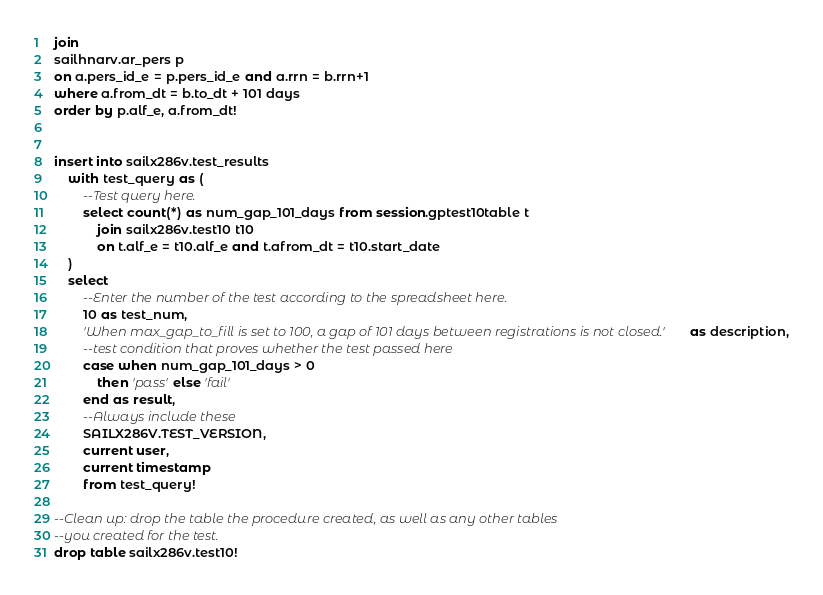<code> <loc_0><loc_0><loc_500><loc_500><_SQL_>join
sailhnarv.ar_pers p
on a.pers_id_e = p.pers_id_e and a.rrn = b.rrn+1
where a.from_dt = b.to_dt + 101 days
order by p.alf_e, a.from_dt!


insert into sailx286v.test_results
	with test_query as (
		--Test query here.
		select count(*) as num_gap_101_days from session.gptest10table t
			join sailx286v.test10 t10
			on t.alf_e = t10.alf_e and t.afrom_dt = t10.start_date
	)
	select 
		--Enter the number of the test according to the spreadsheet here.
		10 as test_num,
		'When max_gap_to_fill is set to 100, a gap of 101 days between registrations is not closed.' as description,
		--test condition that proves whether the test passed here
		case when num_gap_101_days > 0 	
			then 'pass' else 'fail'
		end as result,
		--Always include these
		SAILX286V.TEST_VERSION,
		current user,
		current timestamp
		from test_query!

--Clean up: drop the table the procedure created, as well as any other tables
--you created for the test.
drop table sailx286v.test10!

</code> 